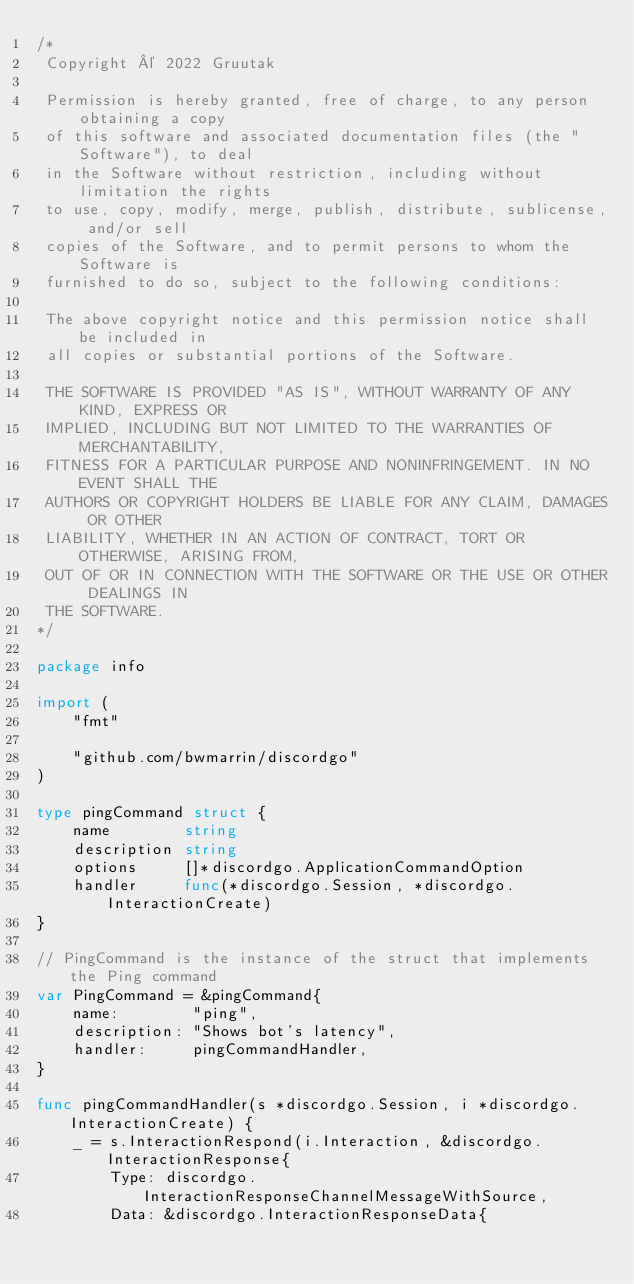Convert code to text. <code><loc_0><loc_0><loc_500><loc_500><_Go_>/*
 Copyright © 2022 Gruutak

 Permission is hereby granted, free of charge, to any person obtaining a copy
 of this software and associated documentation files (the "Software"), to deal
 in the Software without restriction, including without limitation the rights
 to use, copy, modify, merge, publish, distribute, sublicense, and/or sell
 copies of the Software, and to permit persons to whom the Software is
 furnished to do so, subject to the following conditions:

 The above copyright notice and this permission notice shall be included in
 all copies or substantial portions of the Software.

 THE SOFTWARE IS PROVIDED "AS IS", WITHOUT WARRANTY OF ANY KIND, EXPRESS OR
 IMPLIED, INCLUDING BUT NOT LIMITED TO THE WARRANTIES OF MERCHANTABILITY,
 FITNESS FOR A PARTICULAR PURPOSE AND NONINFRINGEMENT. IN NO EVENT SHALL THE
 AUTHORS OR COPYRIGHT HOLDERS BE LIABLE FOR ANY CLAIM, DAMAGES OR OTHER
 LIABILITY, WHETHER IN AN ACTION OF CONTRACT, TORT OR OTHERWISE, ARISING FROM,
 OUT OF OR IN CONNECTION WITH THE SOFTWARE OR THE USE OR OTHER DEALINGS IN
 THE SOFTWARE.
*/

package info

import (
	"fmt"

	"github.com/bwmarrin/discordgo"
)

type pingCommand struct {
	name        string
	description string
	options     []*discordgo.ApplicationCommandOption
	handler     func(*discordgo.Session, *discordgo.InteractionCreate)
}

// PingCommand is the instance of the struct that implements the Ping command
var PingCommand = &pingCommand{
	name:        "ping",
	description: "Shows bot's latency",
	handler:     pingCommandHandler,
}

func pingCommandHandler(s *discordgo.Session, i *discordgo.InteractionCreate) {
	_ = s.InteractionRespond(i.Interaction, &discordgo.InteractionResponse{
		Type: discordgo.InteractionResponseChannelMessageWithSource,
		Data: &discordgo.InteractionResponseData{</code> 